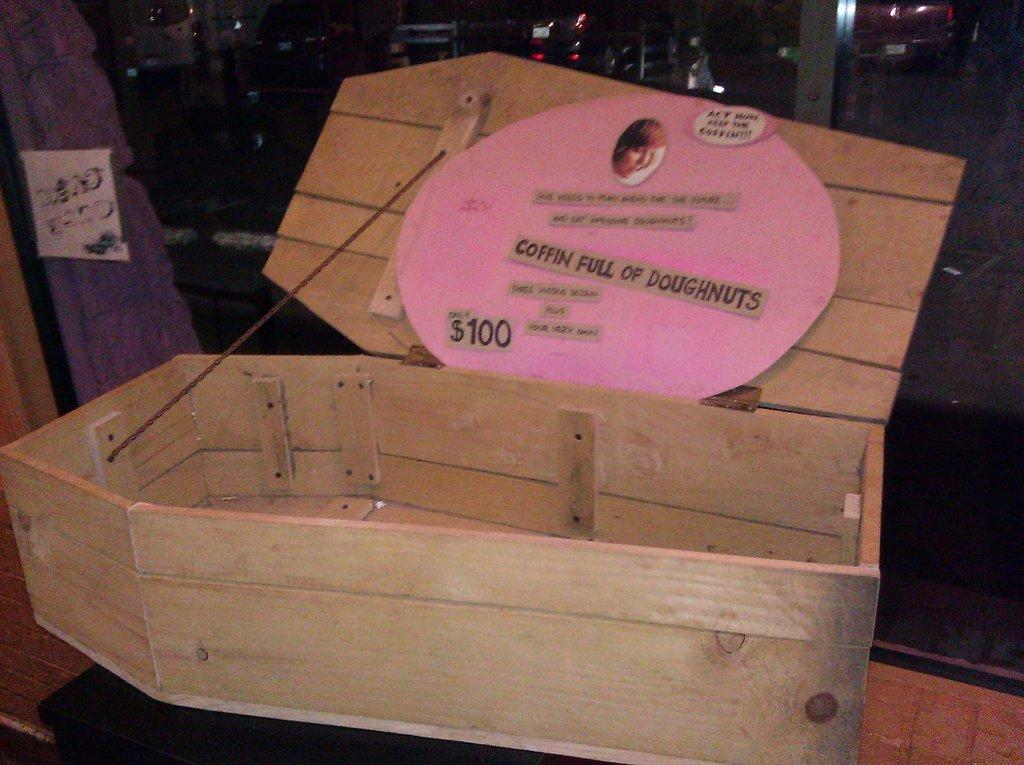<image>
Share a concise interpretation of the image provided. $100 Coffin Full of Doughnuts is shown on this decorative collage. 